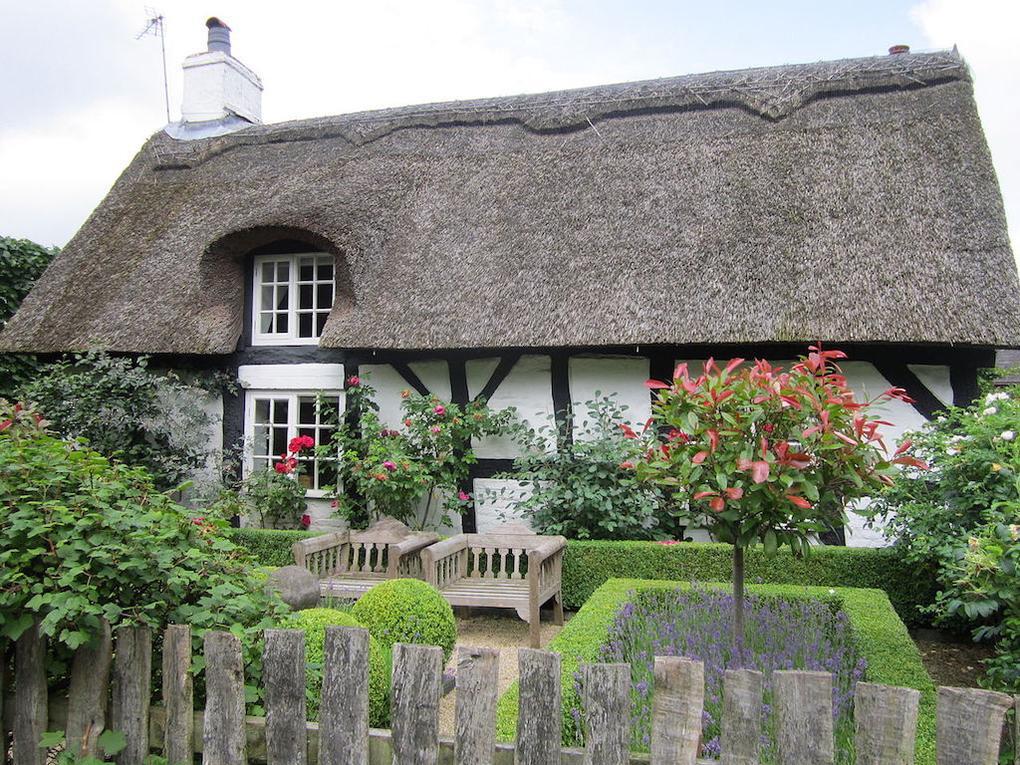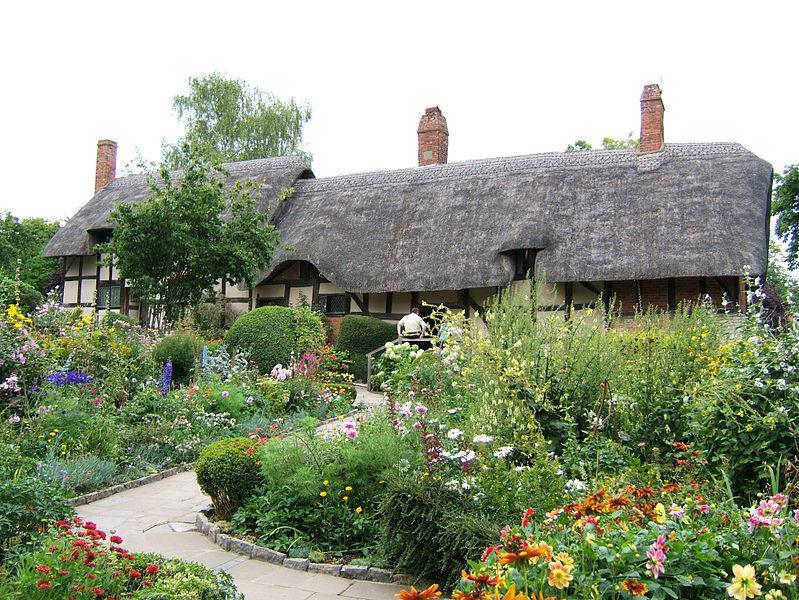The first image is the image on the left, the second image is the image on the right. For the images displayed, is the sentence "The left image shows a white building with at least three notches around windows at the bottom of its gray roof, and a scalloped border along the top of the roof." factually correct? Answer yes or no. No. 